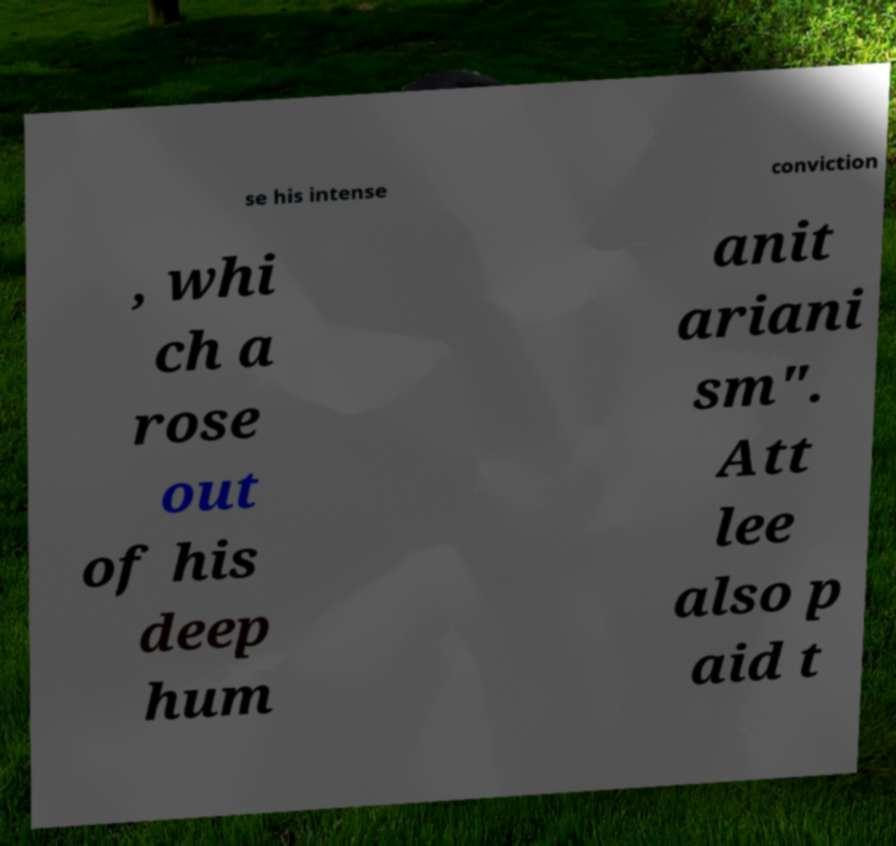Please read and relay the text visible in this image. What does it say? se his intense conviction , whi ch a rose out of his deep hum anit ariani sm". Att lee also p aid t 